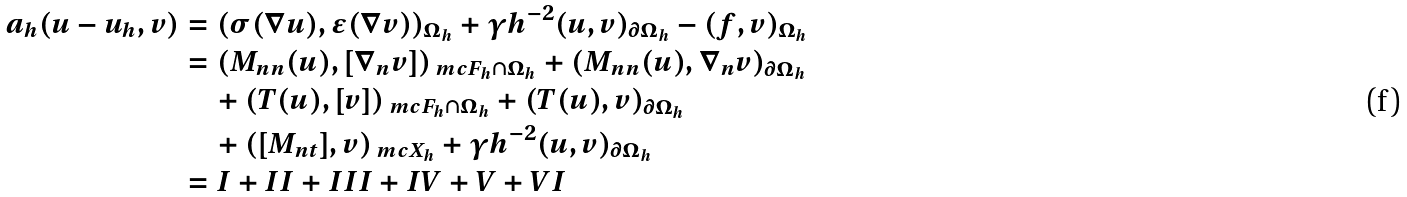Convert formula to latex. <formula><loc_0><loc_0><loc_500><loc_500>a _ { h } ( u - u _ { h } , v ) & = ( \sigma ( \nabla u ) , \epsilon ( \nabla v ) ) _ { \Omega _ { h } } + \gamma h ^ { - 2 } ( u , v ) _ { \partial \Omega _ { h } } - ( f , v ) _ { \Omega _ { h } } \\ & = ( M _ { n n } ( u ) , [ \nabla _ { n } v ] ) _ { \ m c F _ { h } \cap \Omega _ { h } } + ( M _ { n n } ( u ) , \nabla _ { n } v ) _ { \partial \Omega _ { h } } \\ & \quad + ( T ( u ) , [ v ] ) _ { \ m c F _ { h } \cap \Omega _ { h } } + ( T ( u ) , v ) _ { \partial \Omega _ { h } } \\ & \quad + ( [ M _ { n t } ] , v ) _ { \ m c X _ { h } } + \gamma h ^ { - 2 } ( u , v ) _ { \partial \Omega _ { h } } \\ & = I + I I + I I I + I V + V + V I</formula> 